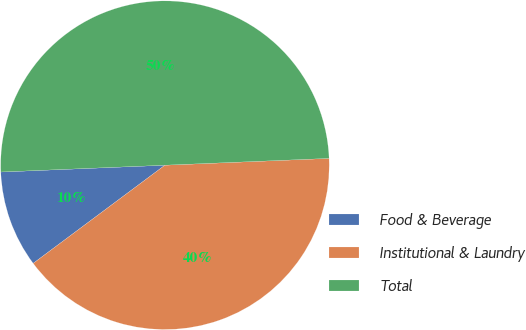Convert chart. <chart><loc_0><loc_0><loc_500><loc_500><pie_chart><fcel>Food & Beverage<fcel>Institutional & Laundry<fcel>Total<nl><fcel>9.53%<fcel>40.47%<fcel>50.0%<nl></chart> 